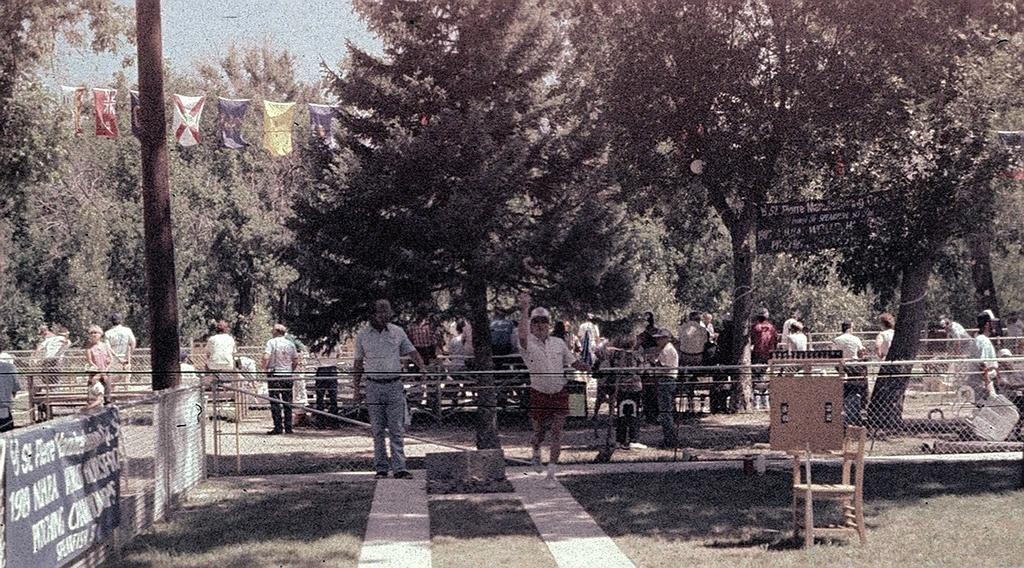Please provide a concise description of this image. In the center of the image some persons are standing and we can see mesh are present. In the background of the image trees are there. At the bottom right corner chair is present. At the top of the image flags are there. At the top of the image sky is present. At the bottom of the image ground and grass are present. 